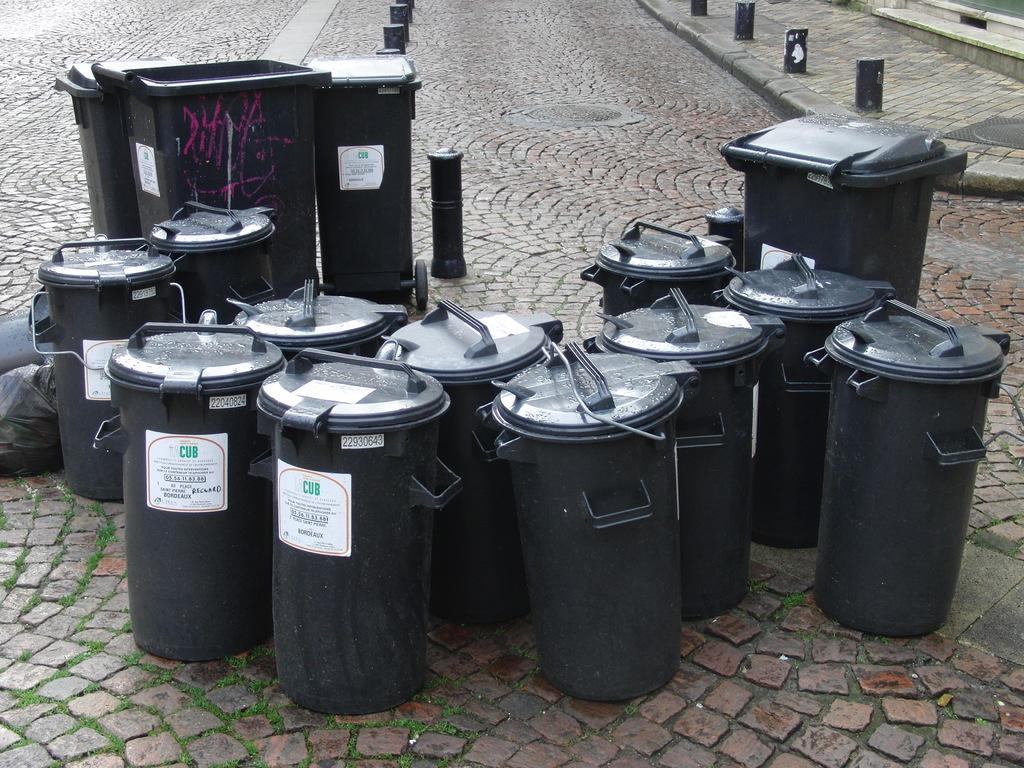What color are the baskets in the image? The baskets in the image are black. What other objects are present in the image? There are trash cans and trash covers in the image. Where are the baskets, trash cans, and trash covers located? They are placed on the road. How many worms can be seen crawling on the trash cans in the image? There are no worms present in the image; it only features baskets, trash cans, and trash covers. 